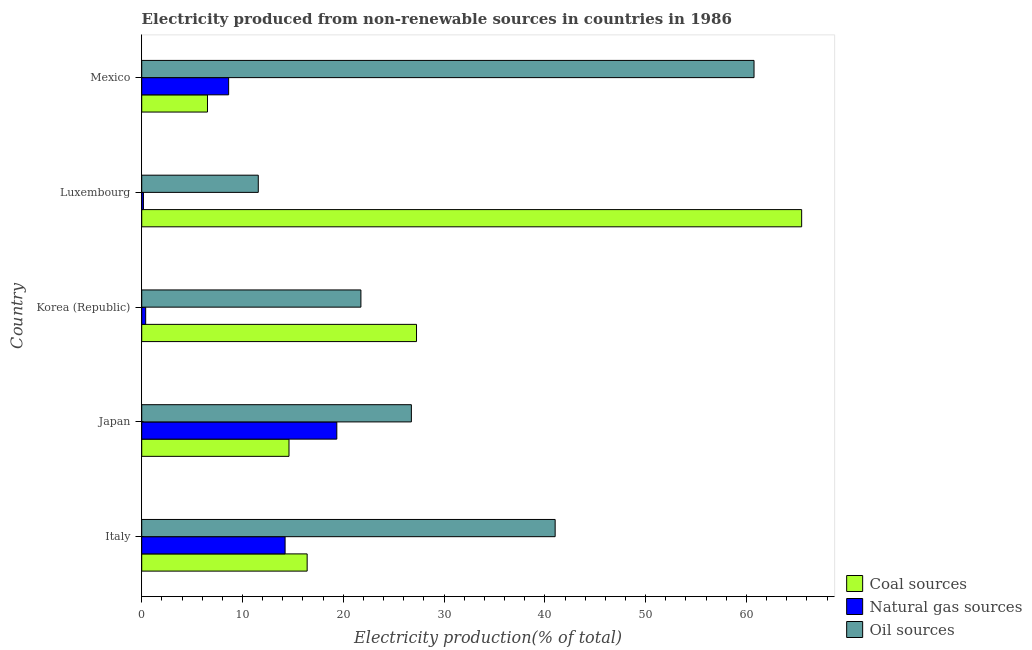Are the number of bars on each tick of the Y-axis equal?
Give a very brief answer. Yes. How many bars are there on the 5th tick from the top?
Your answer should be very brief. 3. How many bars are there on the 4th tick from the bottom?
Ensure brevity in your answer.  3. What is the label of the 3rd group of bars from the top?
Keep it short and to the point. Korea (Republic). What is the percentage of electricity produced by oil sources in Japan?
Your answer should be very brief. 26.75. Across all countries, what is the maximum percentage of electricity produced by natural gas?
Your answer should be compact. 19.36. Across all countries, what is the minimum percentage of electricity produced by natural gas?
Offer a terse response. 0.17. In which country was the percentage of electricity produced by coal maximum?
Ensure brevity in your answer.  Luxembourg. In which country was the percentage of electricity produced by coal minimum?
Your response must be concise. Mexico. What is the total percentage of electricity produced by natural gas in the graph?
Make the answer very short. 42.77. What is the difference between the percentage of electricity produced by oil sources in Korea (Republic) and that in Luxembourg?
Keep it short and to the point. 10.18. What is the difference between the percentage of electricity produced by natural gas in Luxembourg and the percentage of electricity produced by coal in Italy?
Your answer should be compact. -16.24. What is the average percentage of electricity produced by coal per country?
Make the answer very short. 26.06. What is the difference between the percentage of electricity produced by coal and percentage of electricity produced by natural gas in Korea (Republic)?
Your answer should be compact. 26.87. What is the ratio of the percentage of electricity produced by natural gas in Korea (Republic) to that in Luxembourg?
Keep it short and to the point. 2.3. Is the difference between the percentage of electricity produced by coal in Korea (Republic) and Luxembourg greater than the difference between the percentage of electricity produced by natural gas in Korea (Republic) and Luxembourg?
Give a very brief answer. No. What is the difference between the highest and the second highest percentage of electricity produced by oil sources?
Ensure brevity in your answer.  19.73. What is the difference between the highest and the lowest percentage of electricity produced by oil sources?
Ensure brevity in your answer.  49.19. What does the 3rd bar from the top in Japan represents?
Provide a short and direct response. Coal sources. What does the 3rd bar from the bottom in Mexico represents?
Provide a succinct answer. Oil sources. How many bars are there?
Ensure brevity in your answer.  15. Are all the bars in the graph horizontal?
Offer a terse response. Yes. Does the graph contain any zero values?
Offer a very short reply. No. Where does the legend appear in the graph?
Give a very brief answer. Bottom right. What is the title of the graph?
Give a very brief answer. Electricity produced from non-renewable sources in countries in 1986. What is the label or title of the Y-axis?
Offer a terse response. Country. What is the Electricity production(% of total) in Coal sources in Italy?
Provide a short and direct response. 16.41. What is the Electricity production(% of total) in Natural gas sources in Italy?
Make the answer very short. 14.23. What is the Electricity production(% of total) in Oil sources in Italy?
Offer a terse response. 41.02. What is the Electricity production(% of total) of Coal sources in Japan?
Provide a succinct answer. 14.61. What is the Electricity production(% of total) of Natural gas sources in Japan?
Your answer should be compact. 19.36. What is the Electricity production(% of total) of Oil sources in Japan?
Provide a short and direct response. 26.75. What is the Electricity production(% of total) of Coal sources in Korea (Republic)?
Your response must be concise. 27.26. What is the Electricity production(% of total) in Natural gas sources in Korea (Republic)?
Provide a short and direct response. 0.39. What is the Electricity production(% of total) in Oil sources in Korea (Republic)?
Make the answer very short. 21.75. What is the Electricity production(% of total) of Coal sources in Luxembourg?
Your response must be concise. 65.48. What is the Electricity production(% of total) of Natural gas sources in Luxembourg?
Offer a terse response. 0.17. What is the Electricity production(% of total) of Oil sources in Luxembourg?
Make the answer very short. 11.56. What is the Electricity production(% of total) in Coal sources in Mexico?
Give a very brief answer. 6.52. What is the Electricity production(% of total) of Natural gas sources in Mexico?
Make the answer very short. 8.62. What is the Electricity production(% of total) in Oil sources in Mexico?
Your answer should be compact. 60.75. Across all countries, what is the maximum Electricity production(% of total) of Coal sources?
Your answer should be compact. 65.48. Across all countries, what is the maximum Electricity production(% of total) of Natural gas sources?
Give a very brief answer. 19.36. Across all countries, what is the maximum Electricity production(% of total) of Oil sources?
Provide a succinct answer. 60.75. Across all countries, what is the minimum Electricity production(% of total) in Coal sources?
Make the answer very short. 6.52. Across all countries, what is the minimum Electricity production(% of total) of Natural gas sources?
Make the answer very short. 0.17. Across all countries, what is the minimum Electricity production(% of total) in Oil sources?
Give a very brief answer. 11.56. What is the total Electricity production(% of total) in Coal sources in the graph?
Offer a very short reply. 130.29. What is the total Electricity production(% of total) of Natural gas sources in the graph?
Ensure brevity in your answer.  42.77. What is the total Electricity production(% of total) in Oil sources in the graph?
Offer a terse response. 161.84. What is the difference between the Electricity production(% of total) in Coal sources in Italy and that in Japan?
Your answer should be compact. 1.8. What is the difference between the Electricity production(% of total) in Natural gas sources in Italy and that in Japan?
Give a very brief answer. -5.13. What is the difference between the Electricity production(% of total) of Oil sources in Italy and that in Japan?
Your response must be concise. 14.26. What is the difference between the Electricity production(% of total) of Coal sources in Italy and that in Korea (Republic)?
Provide a short and direct response. -10.85. What is the difference between the Electricity production(% of total) in Natural gas sources in Italy and that in Korea (Republic)?
Provide a succinct answer. 13.83. What is the difference between the Electricity production(% of total) in Oil sources in Italy and that in Korea (Republic)?
Give a very brief answer. 19.27. What is the difference between the Electricity production(% of total) of Coal sources in Italy and that in Luxembourg?
Provide a short and direct response. -49.06. What is the difference between the Electricity production(% of total) in Natural gas sources in Italy and that in Luxembourg?
Your answer should be very brief. 14.06. What is the difference between the Electricity production(% of total) in Oil sources in Italy and that in Luxembourg?
Provide a short and direct response. 29.45. What is the difference between the Electricity production(% of total) of Coal sources in Italy and that in Mexico?
Your answer should be very brief. 9.89. What is the difference between the Electricity production(% of total) of Natural gas sources in Italy and that in Mexico?
Provide a succinct answer. 5.6. What is the difference between the Electricity production(% of total) of Oil sources in Italy and that in Mexico?
Provide a succinct answer. -19.73. What is the difference between the Electricity production(% of total) of Coal sources in Japan and that in Korea (Republic)?
Make the answer very short. -12.65. What is the difference between the Electricity production(% of total) of Natural gas sources in Japan and that in Korea (Republic)?
Provide a short and direct response. 18.96. What is the difference between the Electricity production(% of total) in Oil sources in Japan and that in Korea (Republic)?
Provide a short and direct response. 5.01. What is the difference between the Electricity production(% of total) in Coal sources in Japan and that in Luxembourg?
Provide a succinct answer. -50.86. What is the difference between the Electricity production(% of total) of Natural gas sources in Japan and that in Luxembourg?
Keep it short and to the point. 19.19. What is the difference between the Electricity production(% of total) in Oil sources in Japan and that in Luxembourg?
Offer a terse response. 15.19. What is the difference between the Electricity production(% of total) in Coal sources in Japan and that in Mexico?
Provide a short and direct response. 8.09. What is the difference between the Electricity production(% of total) in Natural gas sources in Japan and that in Mexico?
Keep it short and to the point. 10.73. What is the difference between the Electricity production(% of total) in Oil sources in Japan and that in Mexico?
Provide a short and direct response. -34. What is the difference between the Electricity production(% of total) in Coal sources in Korea (Republic) and that in Luxembourg?
Give a very brief answer. -38.21. What is the difference between the Electricity production(% of total) of Natural gas sources in Korea (Republic) and that in Luxembourg?
Keep it short and to the point. 0.22. What is the difference between the Electricity production(% of total) in Oil sources in Korea (Republic) and that in Luxembourg?
Ensure brevity in your answer.  10.18. What is the difference between the Electricity production(% of total) of Coal sources in Korea (Republic) and that in Mexico?
Provide a succinct answer. 20.74. What is the difference between the Electricity production(% of total) in Natural gas sources in Korea (Republic) and that in Mexico?
Make the answer very short. -8.23. What is the difference between the Electricity production(% of total) in Oil sources in Korea (Republic) and that in Mexico?
Make the answer very short. -39. What is the difference between the Electricity production(% of total) in Coal sources in Luxembourg and that in Mexico?
Your response must be concise. 58.95. What is the difference between the Electricity production(% of total) of Natural gas sources in Luxembourg and that in Mexico?
Offer a very short reply. -8.45. What is the difference between the Electricity production(% of total) of Oil sources in Luxembourg and that in Mexico?
Offer a terse response. -49.19. What is the difference between the Electricity production(% of total) of Coal sources in Italy and the Electricity production(% of total) of Natural gas sources in Japan?
Ensure brevity in your answer.  -2.94. What is the difference between the Electricity production(% of total) of Coal sources in Italy and the Electricity production(% of total) of Oil sources in Japan?
Your response must be concise. -10.34. What is the difference between the Electricity production(% of total) of Natural gas sources in Italy and the Electricity production(% of total) of Oil sources in Japan?
Give a very brief answer. -12.53. What is the difference between the Electricity production(% of total) in Coal sources in Italy and the Electricity production(% of total) in Natural gas sources in Korea (Republic)?
Offer a terse response. 16.02. What is the difference between the Electricity production(% of total) in Coal sources in Italy and the Electricity production(% of total) in Oil sources in Korea (Republic)?
Make the answer very short. -5.33. What is the difference between the Electricity production(% of total) of Natural gas sources in Italy and the Electricity production(% of total) of Oil sources in Korea (Republic)?
Ensure brevity in your answer.  -7.52. What is the difference between the Electricity production(% of total) in Coal sources in Italy and the Electricity production(% of total) in Natural gas sources in Luxembourg?
Your response must be concise. 16.24. What is the difference between the Electricity production(% of total) in Coal sources in Italy and the Electricity production(% of total) in Oil sources in Luxembourg?
Your response must be concise. 4.85. What is the difference between the Electricity production(% of total) in Natural gas sources in Italy and the Electricity production(% of total) in Oil sources in Luxembourg?
Your answer should be compact. 2.66. What is the difference between the Electricity production(% of total) of Coal sources in Italy and the Electricity production(% of total) of Natural gas sources in Mexico?
Your answer should be very brief. 7.79. What is the difference between the Electricity production(% of total) in Coal sources in Italy and the Electricity production(% of total) in Oil sources in Mexico?
Provide a short and direct response. -44.34. What is the difference between the Electricity production(% of total) of Natural gas sources in Italy and the Electricity production(% of total) of Oil sources in Mexico?
Your response must be concise. -46.53. What is the difference between the Electricity production(% of total) in Coal sources in Japan and the Electricity production(% of total) in Natural gas sources in Korea (Republic)?
Your answer should be compact. 14.22. What is the difference between the Electricity production(% of total) of Coal sources in Japan and the Electricity production(% of total) of Oil sources in Korea (Republic)?
Give a very brief answer. -7.13. What is the difference between the Electricity production(% of total) in Natural gas sources in Japan and the Electricity production(% of total) in Oil sources in Korea (Republic)?
Your answer should be very brief. -2.39. What is the difference between the Electricity production(% of total) of Coal sources in Japan and the Electricity production(% of total) of Natural gas sources in Luxembourg?
Ensure brevity in your answer.  14.44. What is the difference between the Electricity production(% of total) in Coal sources in Japan and the Electricity production(% of total) in Oil sources in Luxembourg?
Keep it short and to the point. 3.05. What is the difference between the Electricity production(% of total) of Natural gas sources in Japan and the Electricity production(% of total) of Oil sources in Luxembourg?
Ensure brevity in your answer.  7.79. What is the difference between the Electricity production(% of total) of Coal sources in Japan and the Electricity production(% of total) of Natural gas sources in Mexico?
Offer a terse response. 5.99. What is the difference between the Electricity production(% of total) in Coal sources in Japan and the Electricity production(% of total) in Oil sources in Mexico?
Ensure brevity in your answer.  -46.14. What is the difference between the Electricity production(% of total) in Natural gas sources in Japan and the Electricity production(% of total) in Oil sources in Mexico?
Ensure brevity in your answer.  -41.4. What is the difference between the Electricity production(% of total) in Coal sources in Korea (Republic) and the Electricity production(% of total) in Natural gas sources in Luxembourg?
Your response must be concise. 27.09. What is the difference between the Electricity production(% of total) in Coal sources in Korea (Republic) and the Electricity production(% of total) in Oil sources in Luxembourg?
Your response must be concise. 15.7. What is the difference between the Electricity production(% of total) in Natural gas sources in Korea (Republic) and the Electricity production(% of total) in Oil sources in Luxembourg?
Offer a terse response. -11.17. What is the difference between the Electricity production(% of total) in Coal sources in Korea (Republic) and the Electricity production(% of total) in Natural gas sources in Mexico?
Your response must be concise. 18.64. What is the difference between the Electricity production(% of total) of Coal sources in Korea (Republic) and the Electricity production(% of total) of Oil sources in Mexico?
Keep it short and to the point. -33.49. What is the difference between the Electricity production(% of total) in Natural gas sources in Korea (Republic) and the Electricity production(% of total) in Oil sources in Mexico?
Give a very brief answer. -60.36. What is the difference between the Electricity production(% of total) in Coal sources in Luxembourg and the Electricity production(% of total) in Natural gas sources in Mexico?
Your answer should be very brief. 56.85. What is the difference between the Electricity production(% of total) of Coal sources in Luxembourg and the Electricity production(% of total) of Oil sources in Mexico?
Keep it short and to the point. 4.73. What is the difference between the Electricity production(% of total) in Natural gas sources in Luxembourg and the Electricity production(% of total) in Oil sources in Mexico?
Provide a succinct answer. -60.58. What is the average Electricity production(% of total) in Coal sources per country?
Your answer should be compact. 26.06. What is the average Electricity production(% of total) in Natural gas sources per country?
Your answer should be very brief. 8.55. What is the average Electricity production(% of total) of Oil sources per country?
Your answer should be compact. 32.37. What is the difference between the Electricity production(% of total) of Coal sources and Electricity production(% of total) of Natural gas sources in Italy?
Your response must be concise. 2.19. What is the difference between the Electricity production(% of total) of Coal sources and Electricity production(% of total) of Oil sources in Italy?
Give a very brief answer. -24.61. What is the difference between the Electricity production(% of total) in Natural gas sources and Electricity production(% of total) in Oil sources in Italy?
Your answer should be compact. -26.79. What is the difference between the Electricity production(% of total) of Coal sources and Electricity production(% of total) of Natural gas sources in Japan?
Provide a short and direct response. -4.74. What is the difference between the Electricity production(% of total) in Coal sources and Electricity production(% of total) in Oil sources in Japan?
Keep it short and to the point. -12.14. What is the difference between the Electricity production(% of total) of Natural gas sources and Electricity production(% of total) of Oil sources in Japan?
Offer a terse response. -7.4. What is the difference between the Electricity production(% of total) of Coal sources and Electricity production(% of total) of Natural gas sources in Korea (Republic)?
Ensure brevity in your answer.  26.87. What is the difference between the Electricity production(% of total) in Coal sources and Electricity production(% of total) in Oil sources in Korea (Republic)?
Provide a succinct answer. 5.52. What is the difference between the Electricity production(% of total) of Natural gas sources and Electricity production(% of total) of Oil sources in Korea (Republic)?
Ensure brevity in your answer.  -21.36. What is the difference between the Electricity production(% of total) of Coal sources and Electricity production(% of total) of Natural gas sources in Luxembourg?
Your answer should be compact. 65.31. What is the difference between the Electricity production(% of total) in Coal sources and Electricity production(% of total) in Oil sources in Luxembourg?
Offer a terse response. 53.91. What is the difference between the Electricity production(% of total) in Natural gas sources and Electricity production(% of total) in Oil sources in Luxembourg?
Your answer should be very brief. -11.39. What is the difference between the Electricity production(% of total) of Coal sources and Electricity production(% of total) of Natural gas sources in Mexico?
Offer a terse response. -2.1. What is the difference between the Electricity production(% of total) in Coal sources and Electricity production(% of total) in Oil sources in Mexico?
Your answer should be compact. -54.23. What is the difference between the Electricity production(% of total) in Natural gas sources and Electricity production(% of total) in Oil sources in Mexico?
Make the answer very short. -52.13. What is the ratio of the Electricity production(% of total) in Coal sources in Italy to that in Japan?
Your answer should be compact. 1.12. What is the ratio of the Electricity production(% of total) in Natural gas sources in Italy to that in Japan?
Your answer should be very brief. 0.73. What is the ratio of the Electricity production(% of total) in Oil sources in Italy to that in Japan?
Provide a short and direct response. 1.53. What is the ratio of the Electricity production(% of total) of Coal sources in Italy to that in Korea (Republic)?
Your response must be concise. 0.6. What is the ratio of the Electricity production(% of total) in Natural gas sources in Italy to that in Korea (Republic)?
Keep it short and to the point. 36.36. What is the ratio of the Electricity production(% of total) of Oil sources in Italy to that in Korea (Republic)?
Your response must be concise. 1.89. What is the ratio of the Electricity production(% of total) of Coal sources in Italy to that in Luxembourg?
Provide a succinct answer. 0.25. What is the ratio of the Electricity production(% of total) in Natural gas sources in Italy to that in Luxembourg?
Make the answer very short. 83.65. What is the ratio of the Electricity production(% of total) in Oil sources in Italy to that in Luxembourg?
Ensure brevity in your answer.  3.55. What is the ratio of the Electricity production(% of total) of Coal sources in Italy to that in Mexico?
Provide a short and direct response. 2.52. What is the ratio of the Electricity production(% of total) of Natural gas sources in Italy to that in Mexico?
Ensure brevity in your answer.  1.65. What is the ratio of the Electricity production(% of total) in Oil sources in Italy to that in Mexico?
Offer a very short reply. 0.68. What is the ratio of the Electricity production(% of total) in Coal sources in Japan to that in Korea (Republic)?
Offer a terse response. 0.54. What is the ratio of the Electricity production(% of total) of Natural gas sources in Japan to that in Korea (Republic)?
Your answer should be very brief. 49.47. What is the ratio of the Electricity production(% of total) of Oil sources in Japan to that in Korea (Republic)?
Provide a succinct answer. 1.23. What is the ratio of the Electricity production(% of total) of Coal sources in Japan to that in Luxembourg?
Give a very brief answer. 0.22. What is the ratio of the Electricity production(% of total) in Natural gas sources in Japan to that in Luxembourg?
Keep it short and to the point. 113.81. What is the ratio of the Electricity production(% of total) in Oil sources in Japan to that in Luxembourg?
Your response must be concise. 2.31. What is the ratio of the Electricity production(% of total) in Coal sources in Japan to that in Mexico?
Make the answer very short. 2.24. What is the ratio of the Electricity production(% of total) in Natural gas sources in Japan to that in Mexico?
Ensure brevity in your answer.  2.24. What is the ratio of the Electricity production(% of total) in Oil sources in Japan to that in Mexico?
Ensure brevity in your answer.  0.44. What is the ratio of the Electricity production(% of total) of Coal sources in Korea (Republic) to that in Luxembourg?
Your answer should be very brief. 0.42. What is the ratio of the Electricity production(% of total) of Natural gas sources in Korea (Republic) to that in Luxembourg?
Your response must be concise. 2.3. What is the ratio of the Electricity production(% of total) in Oil sources in Korea (Republic) to that in Luxembourg?
Give a very brief answer. 1.88. What is the ratio of the Electricity production(% of total) of Coal sources in Korea (Republic) to that in Mexico?
Give a very brief answer. 4.18. What is the ratio of the Electricity production(% of total) in Natural gas sources in Korea (Republic) to that in Mexico?
Provide a succinct answer. 0.05. What is the ratio of the Electricity production(% of total) of Oil sources in Korea (Republic) to that in Mexico?
Offer a terse response. 0.36. What is the ratio of the Electricity production(% of total) in Coal sources in Luxembourg to that in Mexico?
Your answer should be very brief. 10.04. What is the ratio of the Electricity production(% of total) of Natural gas sources in Luxembourg to that in Mexico?
Give a very brief answer. 0.02. What is the ratio of the Electricity production(% of total) of Oil sources in Luxembourg to that in Mexico?
Your response must be concise. 0.19. What is the difference between the highest and the second highest Electricity production(% of total) in Coal sources?
Provide a succinct answer. 38.21. What is the difference between the highest and the second highest Electricity production(% of total) of Natural gas sources?
Your answer should be compact. 5.13. What is the difference between the highest and the second highest Electricity production(% of total) in Oil sources?
Your answer should be compact. 19.73. What is the difference between the highest and the lowest Electricity production(% of total) of Coal sources?
Offer a very short reply. 58.95. What is the difference between the highest and the lowest Electricity production(% of total) of Natural gas sources?
Provide a succinct answer. 19.19. What is the difference between the highest and the lowest Electricity production(% of total) of Oil sources?
Give a very brief answer. 49.19. 